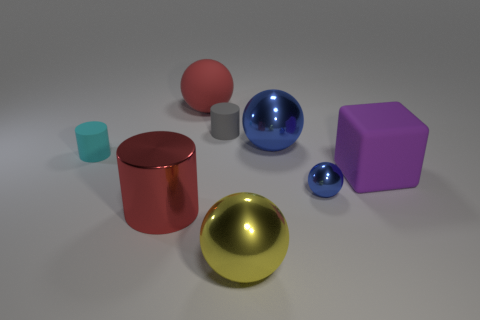Is the number of large red shiny objects greater than the number of blue spheres?
Offer a very short reply. No. What number of blocks have the same color as the small metal ball?
Your answer should be compact. 0. The other large object that is the same shape as the cyan object is what color?
Keep it short and to the point. Red. There is a cylinder that is to the right of the cyan cylinder and in front of the gray cylinder; what is it made of?
Your response must be concise. Metal. Is the material of the blue sphere left of the tiny blue sphere the same as the red thing to the right of the big red cylinder?
Keep it short and to the point. No. The yellow shiny object is what size?
Provide a short and direct response. Large. What size is the red matte thing that is the same shape as the large yellow object?
Offer a very short reply. Large. How many spheres are behind the shiny cylinder?
Ensure brevity in your answer.  3. There is a tiny cylinder to the left of the big red thing that is behind the big purple matte block; what color is it?
Offer a terse response. Cyan. Is there any other thing that has the same shape as the tiny gray matte thing?
Provide a short and direct response. Yes. 